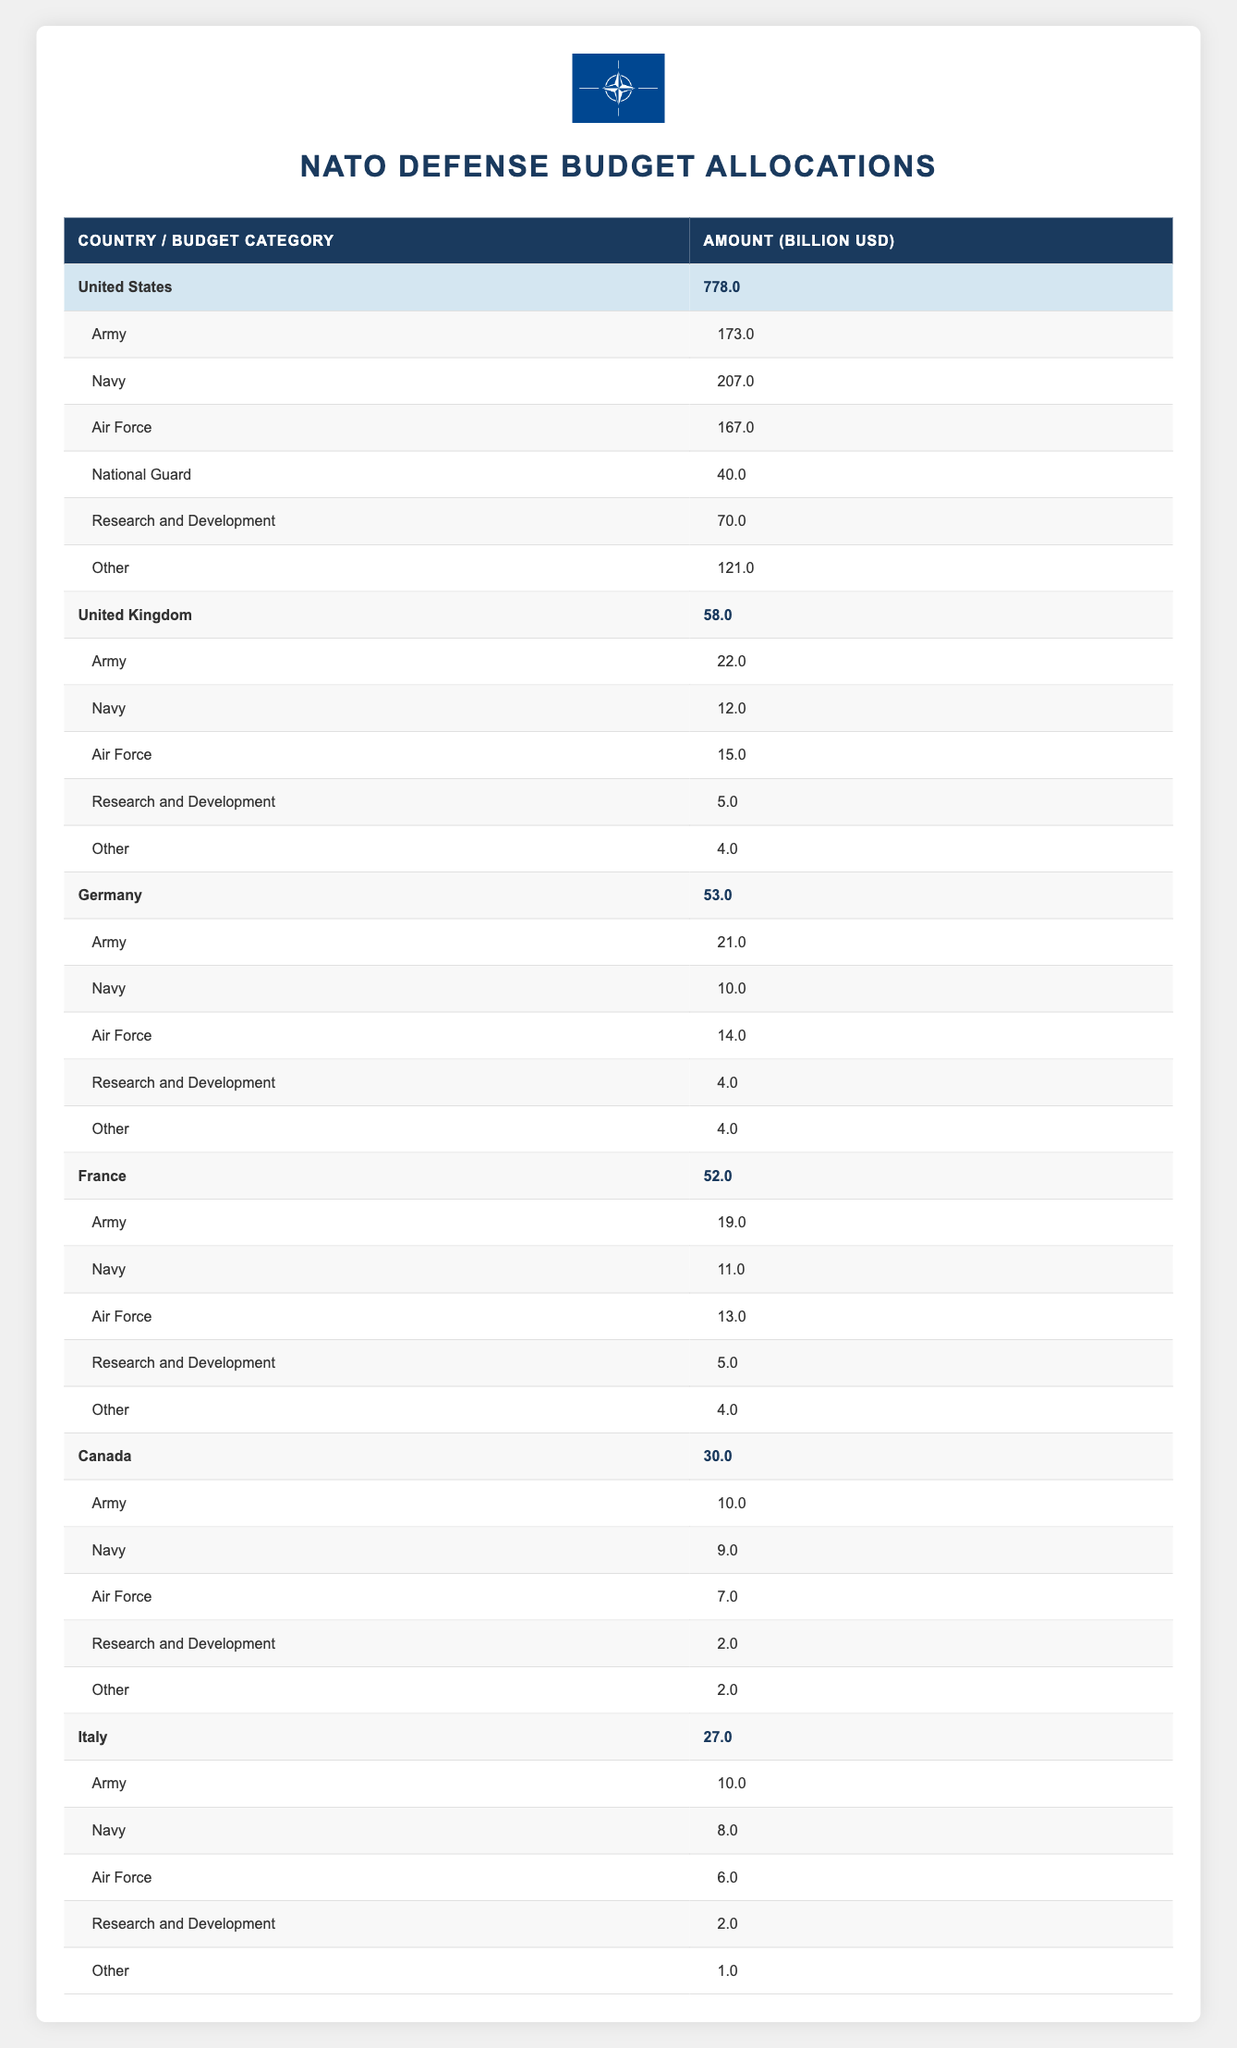What is the total defense budget of the United States? The total defense budget for the United States is listed in the table under the "Total" column for the country, which shows an amount of 778.0.
Answer: 778.0 Which country has the highest budget allocation for the Navy? Comparing the budget allocations for the Navy across all countries in the table, the United States has the highest allocation at 207.0.
Answer: United States What is the average defense budget of the listed NATO member countries? To compute the average, sum up all the defense budgets: (778.0 + 58.0 + 53.0 + 52.0 + 30.0 + 27.0) = 998.0. There are 6 countries, so the average is 998.0 / 6 = 166.33.
Answer: 166.33 Is France's army budget greater than Germany's? From the table, France has an army budget of 19.0 while Germany's army budget is 21.0, indicating that Germany's army budget is greater.
Answer: No How much more does the United States allocate to Research and Development compared to Canada? The table shows that the United States allocates 70.0 for Research and Development while Canada allocates 2.0. The difference is 70.0 - 2.0 = 68.0.
Answer: 68.0 Which NATO member country has the lowest total defense budget? By reviewing the total defense budgets, Canada has the lowest budget at 30.0.
Answer: Canada What percentage of the United Kingdom's defense budget is allocated to the Army? The United Kingdom’s total budget is 58.0, with its army allocation being 22.0. To find the percentage, calculate (22.0 / 58.0) * 100 = 37.93%.
Answer: 37.93% Which two countries have a combined defense budget greater than 750 billion USD? Adding the total budgets, the United States (778.0) combined with any other country must be considered. United States (778.0) already exceeds 750, with no need for another country.
Answer: United States What is the total allocation for the Air Force across all listed countries? Summing the Air Force allocations from each country: (167.0 + 15.0 + 14.0 + 13.0 + 7.0 + 6.0) = 222.0 reveals the total allocation for the Air Force.
Answer: 222.0 